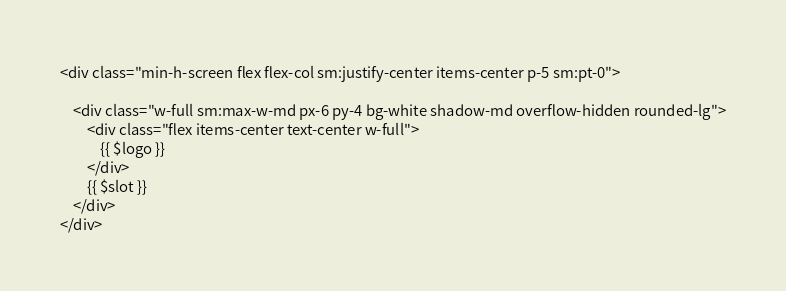Convert code to text. <code><loc_0><loc_0><loc_500><loc_500><_PHP_><div class="min-h-screen flex flex-col sm:justify-center items-center p-5 sm:pt-0">

    <div class="w-full sm:max-w-md px-6 py-4 bg-white shadow-md overflow-hidden rounded-lg">
        <div class="flex items-center text-center w-full">
            {{ $logo }}
        </div>
        {{ $slot }}
    </div>
</div>
</code> 